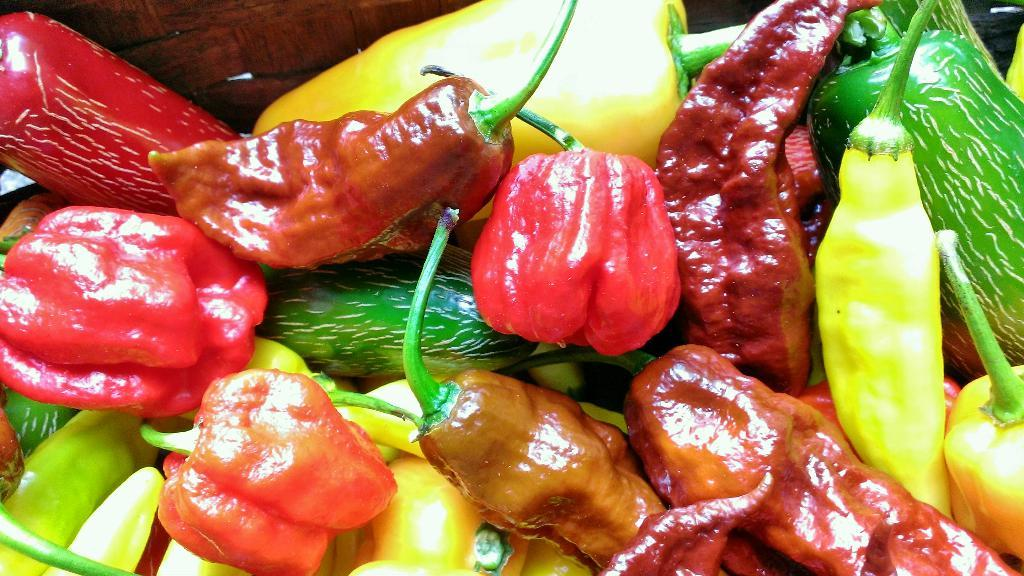What type of chilies can be seen in the image? There are green chilies and red chilies in the image. What else is present in the image besides chilies? There are other vegetables in the image. How are the vegetables arranged in the image? The vegetables are in a basket. What type of cloth is being used to cover the chilies in the image? There is no cloth present in the image; the chilies and other vegetables are visible in a basket. 